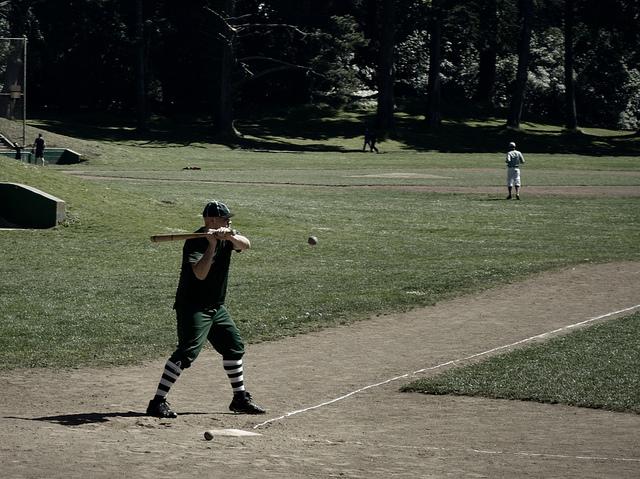What base is the picture facing?
Quick response, please. Home plate. Is this the first softball league?
Be succinct. No. Is there a school bus behind the man?
Concise answer only. No. What color is he wearing?
Be succinct. Green. What game are these people playing?
Write a very short answer. Baseball. What sport is being played?
Keep it brief. Baseball. Is he going to hit or miss the ball?
Keep it brief. Hit. How many players are in the photo?
Short answer required. 2. Is this a fair ball?
Short answer required. Yes. What is the man in black doing?
Short answer required. Batting. What is the man standing behind?
Concise answer only. Home plate. Where is this photo taken?
Write a very short answer. Baseball field. Is this man riding on a skateboard?
Be succinct. No. What is the person holding?
Short answer required. Bat. What is the game?
Give a very brief answer. Baseball. What is the man doing?
Write a very short answer. Playing baseball. What is being used as home plate?
Short answer required. Base. Is this person wearing socks?
Be succinct. Yes. What color is this man's uniform?
Keep it brief. Green. What sport are they playing?
Short answer required. Baseball. What sport is depicted?
Keep it brief. Baseball. What is this person doing?
Concise answer only. Playing baseball. What game is the man playing?
Write a very short answer. Baseball. Is he a pirate?
Be succinct. No. Is the batter right-handed?
Short answer required. Yes. 